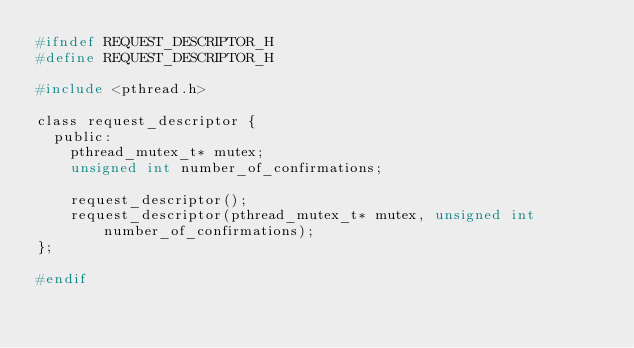<code> <loc_0><loc_0><loc_500><loc_500><_C_>#ifndef REQUEST_DESCRIPTOR_H
#define REQUEST_DESCRIPTOR_H

#include <pthread.h>

class request_descriptor {
	public:
		pthread_mutex_t* mutex;
		unsigned int number_of_confirmations;

		request_descriptor();
		request_descriptor(pthread_mutex_t* mutex, unsigned int number_of_confirmations);
};

#endif
</code> 